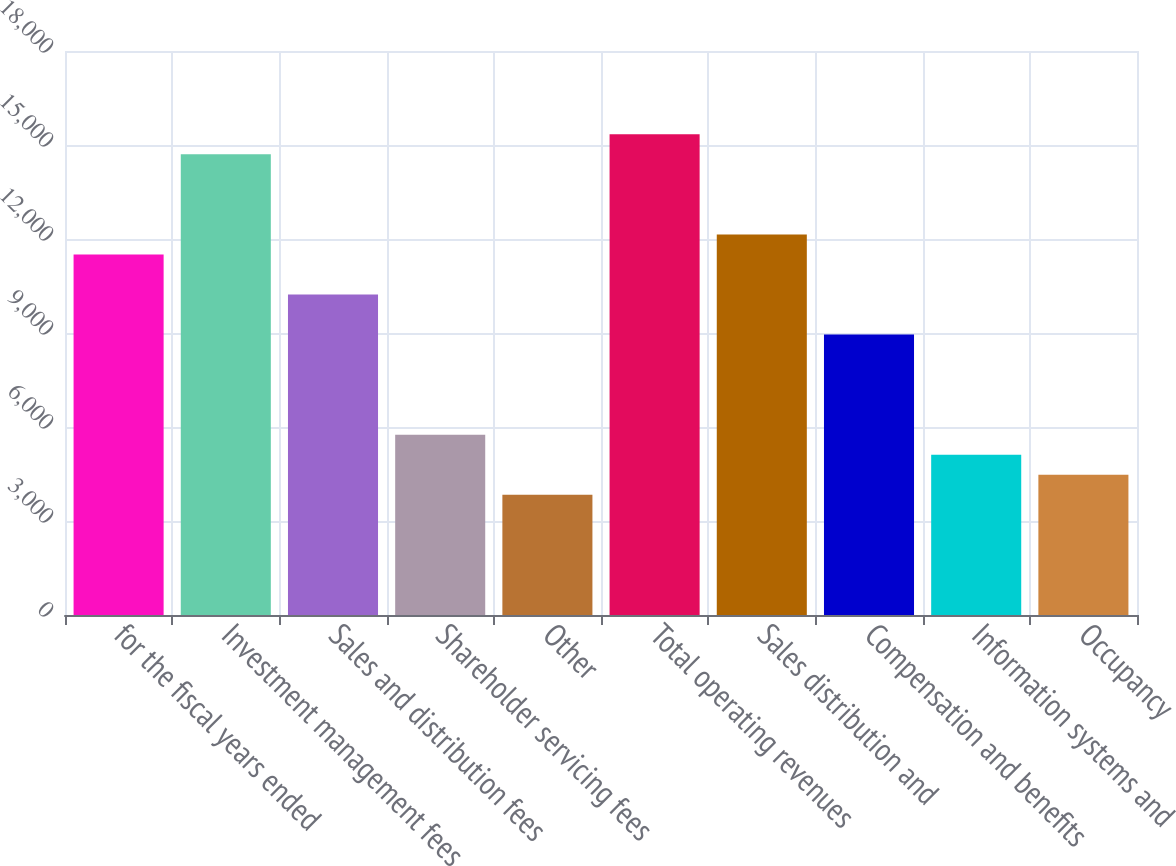Convert chart to OTSL. <chart><loc_0><loc_0><loc_500><loc_500><bar_chart><fcel>for the fiscal years ended<fcel>Investment management fees<fcel>Sales and distribution fees<fcel>Shareholder servicing fees<fcel>Other<fcel>Total operating revenues<fcel>Sales distribution and<fcel>Compensation and benefits<fcel>Information systems and<fcel>Occupancy<nl><fcel>11505.3<fcel>14701<fcel>10227<fcel>5753.06<fcel>3835.64<fcel>15340.2<fcel>12144.5<fcel>8948.76<fcel>5113.92<fcel>4474.78<nl></chart> 